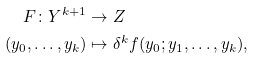<formula> <loc_0><loc_0><loc_500><loc_500>F \colon Y ^ { k + 1 } & \to Z \\ ( y _ { 0 } , \dots , y _ { k } ) & \mapsto \delta ^ { k } f ( y _ { 0 } ; y _ { 1 } , \dots , y _ { k } ) ,</formula> 